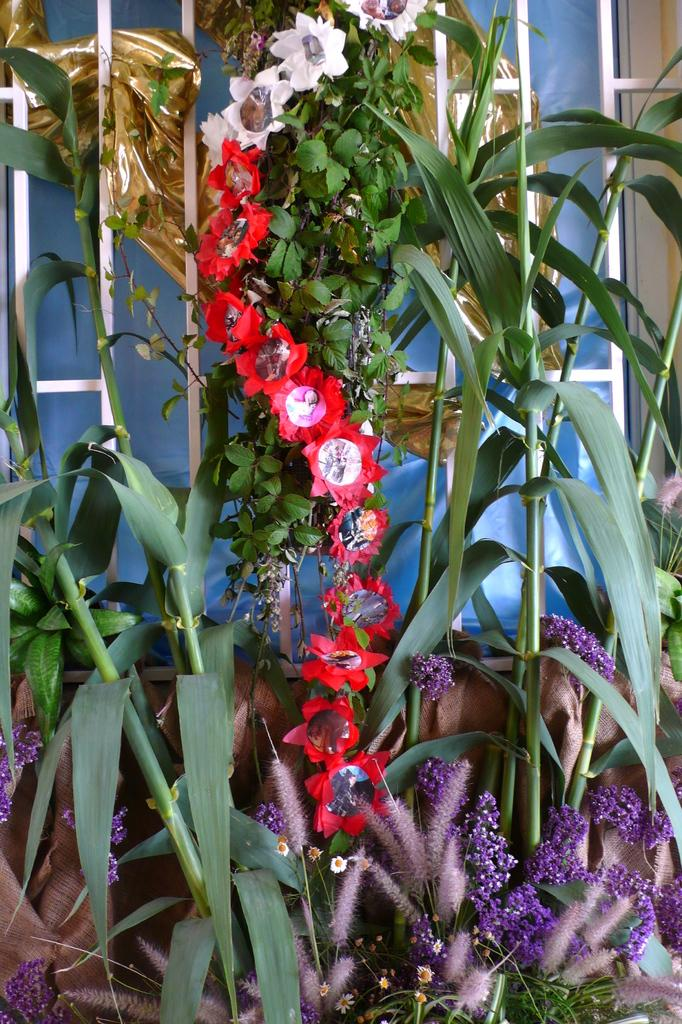What type of living organisms are present in the image? There is a group of plants in the image. What specific feature can be observed on the plants? The plants have flowers. Can you describe any other subjects in the image? There is a girl visible in the image. What is visible in the background of the image? There is a window in the background of the image. How does the girl plan to join the account in the image? There is no mention of an account in the image, as it features a group of plants, a girl, and a window. 